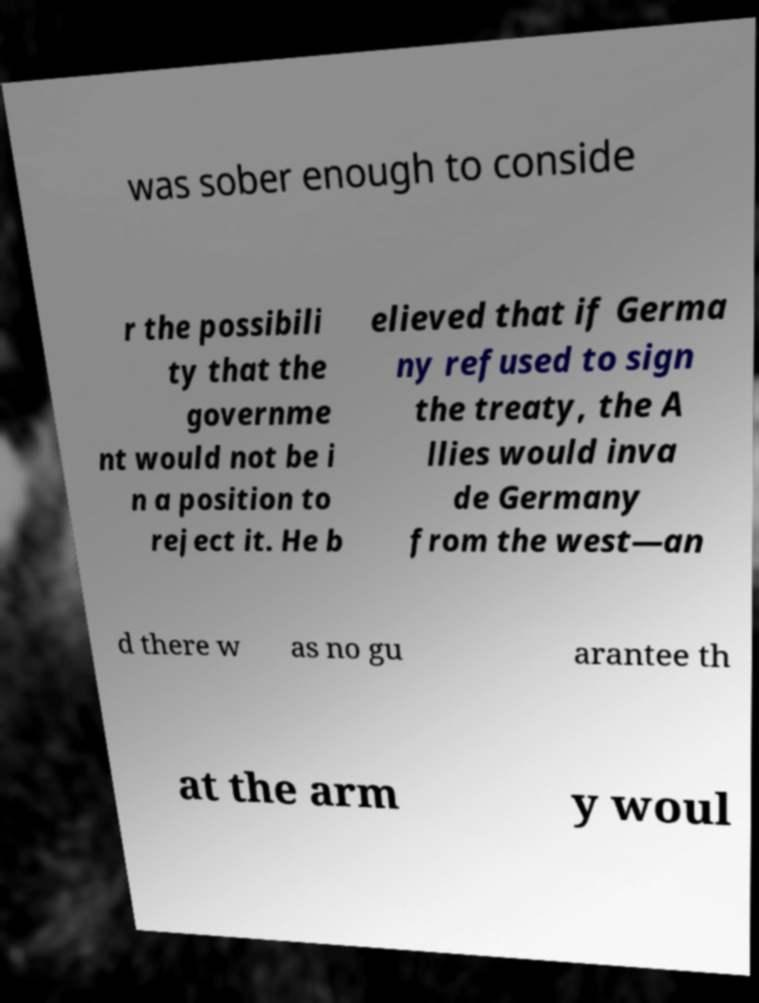There's text embedded in this image that I need extracted. Can you transcribe it verbatim? was sober enough to conside r the possibili ty that the governme nt would not be i n a position to reject it. He b elieved that if Germa ny refused to sign the treaty, the A llies would inva de Germany from the west—an d there w as no gu arantee th at the arm y woul 